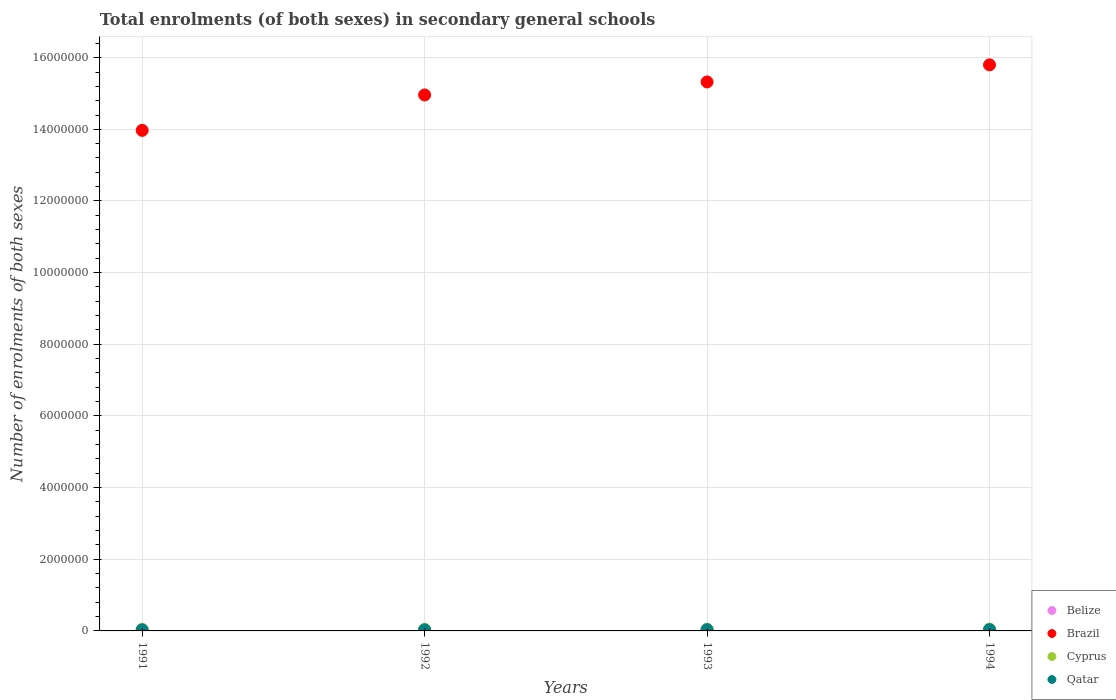How many different coloured dotlines are there?
Your answer should be compact. 4. Is the number of dotlines equal to the number of legend labels?
Your response must be concise. Yes. What is the number of enrolments in secondary schools in Qatar in 1992?
Your answer should be compact. 3.03e+04. Across all years, what is the maximum number of enrolments in secondary schools in Brazil?
Offer a terse response. 1.58e+07. Across all years, what is the minimum number of enrolments in secondary schools in Brazil?
Give a very brief answer. 1.40e+07. In which year was the number of enrolments in secondary schools in Belize maximum?
Ensure brevity in your answer.  1994. What is the total number of enrolments in secondary schools in Qatar in the graph?
Give a very brief answer. 1.29e+05. What is the difference between the number of enrolments in secondary schools in Belize in 1991 and that in 1993?
Offer a terse response. -2189. What is the difference between the number of enrolments in secondary schools in Belize in 1993 and the number of enrolments in secondary schools in Cyprus in 1994?
Give a very brief answer. -3.22e+04. What is the average number of enrolments in secondary schools in Brazil per year?
Your answer should be compact. 1.50e+07. In the year 1994, what is the difference between the number of enrolments in secondary schools in Brazil and number of enrolments in secondary schools in Cyprus?
Your answer should be compact. 1.57e+07. In how many years, is the number of enrolments in secondary schools in Qatar greater than 4400000?
Provide a short and direct response. 0. What is the ratio of the number of enrolments in secondary schools in Qatar in 1993 to that in 1994?
Your answer should be compact. 0.96. What is the difference between the highest and the second highest number of enrolments in secondary schools in Cyprus?
Your answer should be very brief. 2747. What is the difference between the highest and the lowest number of enrolments in secondary schools in Belize?
Keep it short and to the point. 3148. Is the number of enrolments in secondary schools in Brazil strictly greater than the number of enrolments in secondary schools in Qatar over the years?
Provide a short and direct response. Yes. Is the number of enrolments in secondary schools in Qatar strictly less than the number of enrolments in secondary schools in Belize over the years?
Ensure brevity in your answer.  No. What is the difference between two consecutive major ticks on the Y-axis?
Offer a very short reply. 2.00e+06. Are the values on the major ticks of Y-axis written in scientific E-notation?
Give a very brief answer. No. Does the graph contain grids?
Your answer should be very brief. Yes. Where does the legend appear in the graph?
Your response must be concise. Bottom right. How many legend labels are there?
Your response must be concise. 4. What is the title of the graph?
Your answer should be compact. Total enrolments (of both sexes) in secondary general schools. What is the label or title of the X-axis?
Your response must be concise. Years. What is the label or title of the Y-axis?
Give a very brief answer. Number of enrolments of both sexes. What is the Number of enrolments of both sexes in Belize in 1991?
Offer a terse response. 1.64e+04. What is the Number of enrolments of both sexes of Brazil in 1991?
Your answer should be very brief. 1.40e+07. What is the Number of enrolments of both sexes of Cyprus in 1991?
Your answer should be compact. 4.16e+04. What is the Number of enrolments of both sexes of Qatar in 1991?
Offer a very short reply. 2.92e+04. What is the Number of enrolments of both sexes of Belize in 1992?
Offer a terse response. 1.77e+04. What is the Number of enrolments of both sexes of Brazil in 1992?
Offer a very short reply. 1.50e+07. What is the Number of enrolments of both sexes in Cyprus in 1992?
Keep it short and to the point. 4.47e+04. What is the Number of enrolments of both sexes of Qatar in 1992?
Provide a short and direct response. 3.03e+04. What is the Number of enrolments of both sexes of Belize in 1993?
Offer a very short reply. 1.86e+04. What is the Number of enrolments of both sexes in Brazil in 1993?
Give a very brief answer. 1.53e+07. What is the Number of enrolments of both sexes in Cyprus in 1993?
Keep it short and to the point. 4.81e+04. What is the Number of enrolments of both sexes of Qatar in 1993?
Offer a very short reply. 3.42e+04. What is the Number of enrolments of both sexes of Belize in 1994?
Provide a short and direct response. 1.96e+04. What is the Number of enrolments of both sexes in Brazil in 1994?
Keep it short and to the point. 1.58e+07. What is the Number of enrolments of both sexes of Cyprus in 1994?
Provide a short and direct response. 5.09e+04. What is the Number of enrolments of both sexes of Qatar in 1994?
Your answer should be compact. 3.55e+04. Across all years, what is the maximum Number of enrolments of both sexes of Belize?
Provide a short and direct response. 1.96e+04. Across all years, what is the maximum Number of enrolments of both sexes of Brazil?
Make the answer very short. 1.58e+07. Across all years, what is the maximum Number of enrolments of both sexes of Cyprus?
Provide a succinct answer. 5.09e+04. Across all years, what is the maximum Number of enrolments of both sexes in Qatar?
Your answer should be very brief. 3.55e+04. Across all years, what is the minimum Number of enrolments of both sexes in Belize?
Your answer should be very brief. 1.64e+04. Across all years, what is the minimum Number of enrolments of both sexes in Brazil?
Give a very brief answer. 1.40e+07. Across all years, what is the minimum Number of enrolments of both sexes of Cyprus?
Provide a short and direct response. 4.16e+04. Across all years, what is the minimum Number of enrolments of both sexes in Qatar?
Your response must be concise. 2.92e+04. What is the total Number of enrolments of both sexes of Belize in the graph?
Make the answer very short. 7.24e+04. What is the total Number of enrolments of both sexes of Brazil in the graph?
Make the answer very short. 6.01e+07. What is the total Number of enrolments of both sexes in Cyprus in the graph?
Offer a very short reply. 1.85e+05. What is the total Number of enrolments of both sexes in Qatar in the graph?
Keep it short and to the point. 1.29e+05. What is the difference between the Number of enrolments of both sexes of Belize in 1991 and that in 1992?
Your answer should be compact. -1246. What is the difference between the Number of enrolments of both sexes in Brazil in 1991 and that in 1992?
Keep it short and to the point. -9.89e+05. What is the difference between the Number of enrolments of both sexes in Cyprus in 1991 and that in 1992?
Provide a short and direct response. -3152. What is the difference between the Number of enrolments of both sexes of Qatar in 1991 and that in 1992?
Ensure brevity in your answer.  -1123. What is the difference between the Number of enrolments of both sexes of Belize in 1991 and that in 1993?
Provide a short and direct response. -2189. What is the difference between the Number of enrolments of both sexes of Brazil in 1991 and that in 1993?
Make the answer very short. -1.35e+06. What is the difference between the Number of enrolments of both sexes in Cyprus in 1991 and that in 1993?
Offer a terse response. -6539. What is the difference between the Number of enrolments of both sexes of Qatar in 1991 and that in 1993?
Provide a succinct answer. -5077. What is the difference between the Number of enrolments of both sexes in Belize in 1991 and that in 1994?
Keep it short and to the point. -3148. What is the difference between the Number of enrolments of both sexes in Brazil in 1991 and that in 1994?
Your answer should be very brief. -1.83e+06. What is the difference between the Number of enrolments of both sexes of Cyprus in 1991 and that in 1994?
Your response must be concise. -9286. What is the difference between the Number of enrolments of both sexes of Qatar in 1991 and that in 1994?
Ensure brevity in your answer.  -6364. What is the difference between the Number of enrolments of both sexes in Belize in 1992 and that in 1993?
Provide a succinct answer. -943. What is the difference between the Number of enrolments of both sexes in Brazil in 1992 and that in 1993?
Your answer should be very brief. -3.62e+05. What is the difference between the Number of enrolments of both sexes of Cyprus in 1992 and that in 1993?
Your response must be concise. -3387. What is the difference between the Number of enrolments of both sexes of Qatar in 1992 and that in 1993?
Provide a short and direct response. -3954. What is the difference between the Number of enrolments of both sexes of Belize in 1992 and that in 1994?
Provide a succinct answer. -1902. What is the difference between the Number of enrolments of both sexes of Brazil in 1992 and that in 1994?
Make the answer very short. -8.40e+05. What is the difference between the Number of enrolments of both sexes in Cyprus in 1992 and that in 1994?
Your answer should be very brief. -6134. What is the difference between the Number of enrolments of both sexes of Qatar in 1992 and that in 1994?
Keep it short and to the point. -5241. What is the difference between the Number of enrolments of both sexes of Belize in 1993 and that in 1994?
Provide a short and direct response. -959. What is the difference between the Number of enrolments of both sexes in Brazil in 1993 and that in 1994?
Offer a terse response. -4.77e+05. What is the difference between the Number of enrolments of both sexes in Cyprus in 1993 and that in 1994?
Your answer should be compact. -2747. What is the difference between the Number of enrolments of both sexes in Qatar in 1993 and that in 1994?
Give a very brief answer. -1287. What is the difference between the Number of enrolments of both sexes of Belize in 1991 and the Number of enrolments of both sexes of Brazil in 1992?
Your answer should be very brief. -1.49e+07. What is the difference between the Number of enrolments of both sexes in Belize in 1991 and the Number of enrolments of both sexes in Cyprus in 1992?
Give a very brief answer. -2.83e+04. What is the difference between the Number of enrolments of both sexes of Belize in 1991 and the Number of enrolments of both sexes of Qatar in 1992?
Offer a terse response. -1.38e+04. What is the difference between the Number of enrolments of both sexes of Brazil in 1991 and the Number of enrolments of both sexes of Cyprus in 1992?
Provide a short and direct response. 1.39e+07. What is the difference between the Number of enrolments of both sexes of Brazil in 1991 and the Number of enrolments of both sexes of Qatar in 1992?
Offer a terse response. 1.39e+07. What is the difference between the Number of enrolments of both sexes in Cyprus in 1991 and the Number of enrolments of both sexes in Qatar in 1992?
Keep it short and to the point. 1.13e+04. What is the difference between the Number of enrolments of both sexes in Belize in 1991 and the Number of enrolments of both sexes in Brazil in 1993?
Your answer should be compact. -1.53e+07. What is the difference between the Number of enrolments of both sexes in Belize in 1991 and the Number of enrolments of both sexes in Cyprus in 1993?
Keep it short and to the point. -3.17e+04. What is the difference between the Number of enrolments of both sexes in Belize in 1991 and the Number of enrolments of both sexes in Qatar in 1993?
Offer a very short reply. -1.78e+04. What is the difference between the Number of enrolments of both sexes of Brazil in 1991 and the Number of enrolments of both sexes of Cyprus in 1993?
Keep it short and to the point. 1.39e+07. What is the difference between the Number of enrolments of both sexes in Brazil in 1991 and the Number of enrolments of both sexes in Qatar in 1993?
Your answer should be very brief. 1.39e+07. What is the difference between the Number of enrolments of both sexes in Cyprus in 1991 and the Number of enrolments of both sexes in Qatar in 1993?
Give a very brief answer. 7353. What is the difference between the Number of enrolments of both sexes of Belize in 1991 and the Number of enrolments of both sexes of Brazil in 1994?
Make the answer very short. -1.58e+07. What is the difference between the Number of enrolments of both sexes in Belize in 1991 and the Number of enrolments of both sexes in Cyprus in 1994?
Make the answer very short. -3.44e+04. What is the difference between the Number of enrolments of both sexes of Belize in 1991 and the Number of enrolments of both sexes of Qatar in 1994?
Make the answer very short. -1.91e+04. What is the difference between the Number of enrolments of both sexes in Brazil in 1991 and the Number of enrolments of both sexes in Cyprus in 1994?
Your answer should be very brief. 1.39e+07. What is the difference between the Number of enrolments of both sexes of Brazil in 1991 and the Number of enrolments of both sexes of Qatar in 1994?
Offer a terse response. 1.39e+07. What is the difference between the Number of enrolments of both sexes of Cyprus in 1991 and the Number of enrolments of both sexes of Qatar in 1994?
Keep it short and to the point. 6066. What is the difference between the Number of enrolments of both sexes of Belize in 1992 and the Number of enrolments of both sexes of Brazil in 1993?
Offer a terse response. -1.53e+07. What is the difference between the Number of enrolments of both sexes in Belize in 1992 and the Number of enrolments of both sexes in Cyprus in 1993?
Ensure brevity in your answer.  -3.04e+04. What is the difference between the Number of enrolments of both sexes in Belize in 1992 and the Number of enrolments of both sexes in Qatar in 1993?
Your response must be concise. -1.65e+04. What is the difference between the Number of enrolments of both sexes of Brazil in 1992 and the Number of enrolments of both sexes of Cyprus in 1993?
Offer a very short reply. 1.49e+07. What is the difference between the Number of enrolments of both sexes of Brazil in 1992 and the Number of enrolments of both sexes of Qatar in 1993?
Make the answer very short. 1.49e+07. What is the difference between the Number of enrolments of both sexes in Cyprus in 1992 and the Number of enrolments of both sexes in Qatar in 1993?
Provide a short and direct response. 1.05e+04. What is the difference between the Number of enrolments of both sexes of Belize in 1992 and the Number of enrolments of both sexes of Brazil in 1994?
Ensure brevity in your answer.  -1.58e+07. What is the difference between the Number of enrolments of both sexes of Belize in 1992 and the Number of enrolments of both sexes of Cyprus in 1994?
Ensure brevity in your answer.  -3.32e+04. What is the difference between the Number of enrolments of both sexes in Belize in 1992 and the Number of enrolments of both sexes in Qatar in 1994?
Make the answer very short. -1.78e+04. What is the difference between the Number of enrolments of both sexes of Brazil in 1992 and the Number of enrolments of both sexes of Cyprus in 1994?
Offer a very short reply. 1.49e+07. What is the difference between the Number of enrolments of both sexes in Brazil in 1992 and the Number of enrolments of both sexes in Qatar in 1994?
Provide a succinct answer. 1.49e+07. What is the difference between the Number of enrolments of both sexes in Cyprus in 1992 and the Number of enrolments of both sexes in Qatar in 1994?
Offer a terse response. 9218. What is the difference between the Number of enrolments of both sexes in Belize in 1993 and the Number of enrolments of both sexes in Brazil in 1994?
Provide a short and direct response. -1.58e+07. What is the difference between the Number of enrolments of both sexes of Belize in 1993 and the Number of enrolments of both sexes of Cyprus in 1994?
Provide a short and direct response. -3.22e+04. What is the difference between the Number of enrolments of both sexes in Belize in 1993 and the Number of enrolments of both sexes in Qatar in 1994?
Provide a succinct answer. -1.69e+04. What is the difference between the Number of enrolments of both sexes of Brazil in 1993 and the Number of enrolments of both sexes of Cyprus in 1994?
Ensure brevity in your answer.  1.53e+07. What is the difference between the Number of enrolments of both sexes in Brazil in 1993 and the Number of enrolments of both sexes in Qatar in 1994?
Ensure brevity in your answer.  1.53e+07. What is the difference between the Number of enrolments of both sexes of Cyprus in 1993 and the Number of enrolments of both sexes of Qatar in 1994?
Your answer should be very brief. 1.26e+04. What is the average Number of enrolments of both sexes in Belize per year?
Your answer should be compact. 1.81e+04. What is the average Number of enrolments of both sexes in Brazil per year?
Provide a succinct answer. 1.50e+07. What is the average Number of enrolments of both sexes in Cyprus per year?
Offer a terse response. 4.63e+04. What is the average Number of enrolments of both sexes in Qatar per year?
Ensure brevity in your answer.  3.23e+04. In the year 1991, what is the difference between the Number of enrolments of both sexes in Belize and Number of enrolments of both sexes in Brazil?
Offer a very short reply. -1.40e+07. In the year 1991, what is the difference between the Number of enrolments of both sexes of Belize and Number of enrolments of both sexes of Cyprus?
Keep it short and to the point. -2.51e+04. In the year 1991, what is the difference between the Number of enrolments of both sexes of Belize and Number of enrolments of both sexes of Qatar?
Provide a succinct answer. -1.27e+04. In the year 1991, what is the difference between the Number of enrolments of both sexes of Brazil and Number of enrolments of both sexes of Cyprus?
Give a very brief answer. 1.39e+07. In the year 1991, what is the difference between the Number of enrolments of both sexes of Brazil and Number of enrolments of both sexes of Qatar?
Keep it short and to the point. 1.39e+07. In the year 1991, what is the difference between the Number of enrolments of both sexes in Cyprus and Number of enrolments of both sexes in Qatar?
Make the answer very short. 1.24e+04. In the year 1992, what is the difference between the Number of enrolments of both sexes in Belize and Number of enrolments of both sexes in Brazil?
Offer a terse response. -1.49e+07. In the year 1992, what is the difference between the Number of enrolments of both sexes in Belize and Number of enrolments of both sexes in Cyprus?
Offer a very short reply. -2.70e+04. In the year 1992, what is the difference between the Number of enrolments of both sexes of Belize and Number of enrolments of both sexes of Qatar?
Make the answer very short. -1.26e+04. In the year 1992, what is the difference between the Number of enrolments of both sexes of Brazil and Number of enrolments of both sexes of Cyprus?
Provide a short and direct response. 1.49e+07. In the year 1992, what is the difference between the Number of enrolments of both sexes in Brazil and Number of enrolments of both sexes in Qatar?
Give a very brief answer. 1.49e+07. In the year 1992, what is the difference between the Number of enrolments of both sexes of Cyprus and Number of enrolments of both sexes of Qatar?
Provide a short and direct response. 1.45e+04. In the year 1993, what is the difference between the Number of enrolments of both sexes of Belize and Number of enrolments of both sexes of Brazil?
Your answer should be very brief. -1.53e+07. In the year 1993, what is the difference between the Number of enrolments of both sexes of Belize and Number of enrolments of both sexes of Cyprus?
Your answer should be compact. -2.95e+04. In the year 1993, what is the difference between the Number of enrolments of both sexes in Belize and Number of enrolments of both sexes in Qatar?
Make the answer very short. -1.56e+04. In the year 1993, what is the difference between the Number of enrolments of both sexes in Brazil and Number of enrolments of both sexes in Cyprus?
Offer a terse response. 1.53e+07. In the year 1993, what is the difference between the Number of enrolments of both sexes of Brazil and Number of enrolments of both sexes of Qatar?
Your answer should be very brief. 1.53e+07. In the year 1993, what is the difference between the Number of enrolments of both sexes of Cyprus and Number of enrolments of both sexes of Qatar?
Give a very brief answer. 1.39e+04. In the year 1994, what is the difference between the Number of enrolments of both sexes in Belize and Number of enrolments of both sexes in Brazil?
Offer a very short reply. -1.58e+07. In the year 1994, what is the difference between the Number of enrolments of both sexes of Belize and Number of enrolments of both sexes of Cyprus?
Offer a very short reply. -3.13e+04. In the year 1994, what is the difference between the Number of enrolments of both sexes in Belize and Number of enrolments of both sexes in Qatar?
Give a very brief answer. -1.59e+04. In the year 1994, what is the difference between the Number of enrolments of both sexes in Brazil and Number of enrolments of both sexes in Cyprus?
Your response must be concise. 1.57e+07. In the year 1994, what is the difference between the Number of enrolments of both sexes in Brazil and Number of enrolments of both sexes in Qatar?
Your answer should be compact. 1.58e+07. In the year 1994, what is the difference between the Number of enrolments of both sexes of Cyprus and Number of enrolments of both sexes of Qatar?
Provide a succinct answer. 1.54e+04. What is the ratio of the Number of enrolments of both sexes of Belize in 1991 to that in 1992?
Your response must be concise. 0.93. What is the ratio of the Number of enrolments of both sexes in Brazil in 1991 to that in 1992?
Make the answer very short. 0.93. What is the ratio of the Number of enrolments of both sexes of Cyprus in 1991 to that in 1992?
Make the answer very short. 0.93. What is the ratio of the Number of enrolments of both sexes of Qatar in 1991 to that in 1992?
Offer a very short reply. 0.96. What is the ratio of the Number of enrolments of both sexes of Belize in 1991 to that in 1993?
Give a very brief answer. 0.88. What is the ratio of the Number of enrolments of both sexes in Brazil in 1991 to that in 1993?
Your response must be concise. 0.91. What is the ratio of the Number of enrolments of both sexes of Cyprus in 1991 to that in 1993?
Your answer should be very brief. 0.86. What is the ratio of the Number of enrolments of both sexes in Qatar in 1991 to that in 1993?
Provide a succinct answer. 0.85. What is the ratio of the Number of enrolments of both sexes of Belize in 1991 to that in 1994?
Offer a terse response. 0.84. What is the ratio of the Number of enrolments of both sexes of Brazil in 1991 to that in 1994?
Your answer should be very brief. 0.88. What is the ratio of the Number of enrolments of both sexes of Cyprus in 1991 to that in 1994?
Offer a terse response. 0.82. What is the ratio of the Number of enrolments of both sexes in Qatar in 1991 to that in 1994?
Offer a very short reply. 0.82. What is the ratio of the Number of enrolments of both sexes in Belize in 1992 to that in 1993?
Keep it short and to the point. 0.95. What is the ratio of the Number of enrolments of both sexes of Brazil in 1992 to that in 1993?
Ensure brevity in your answer.  0.98. What is the ratio of the Number of enrolments of both sexes of Cyprus in 1992 to that in 1993?
Keep it short and to the point. 0.93. What is the ratio of the Number of enrolments of both sexes of Qatar in 1992 to that in 1993?
Provide a short and direct response. 0.88. What is the ratio of the Number of enrolments of both sexes of Belize in 1992 to that in 1994?
Offer a very short reply. 0.9. What is the ratio of the Number of enrolments of both sexes in Brazil in 1992 to that in 1994?
Give a very brief answer. 0.95. What is the ratio of the Number of enrolments of both sexes of Cyprus in 1992 to that in 1994?
Offer a terse response. 0.88. What is the ratio of the Number of enrolments of both sexes of Qatar in 1992 to that in 1994?
Make the answer very short. 0.85. What is the ratio of the Number of enrolments of both sexes in Belize in 1993 to that in 1994?
Your answer should be compact. 0.95. What is the ratio of the Number of enrolments of both sexes of Brazil in 1993 to that in 1994?
Your answer should be compact. 0.97. What is the ratio of the Number of enrolments of both sexes in Cyprus in 1993 to that in 1994?
Offer a very short reply. 0.95. What is the ratio of the Number of enrolments of both sexes of Qatar in 1993 to that in 1994?
Your answer should be compact. 0.96. What is the difference between the highest and the second highest Number of enrolments of both sexes in Belize?
Make the answer very short. 959. What is the difference between the highest and the second highest Number of enrolments of both sexes in Brazil?
Keep it short and to the point. 4.77e+05. What is the difference between the highest and the second highest Number of enrolments of both sexes in Cyprus?
Give a very brief answer. 2747. What is the difference between the highest and the second highest Number of enrolments of both sexes of Qatar?
Provide a succinct answer. 1287. What is the difference between the highest and the lowest Number of enrolments of both sexes of Belize?
Your answer should be compact. 3148. What is the difference between the highest and the lowest Number of enrolments of both sexes in Brazil?
Offer a terse response. 1.83e+06. What is the difference between the highest and the lowest Number of enrolments of both sexes in Cyprus?
Keep it short and to the point. 9286. What is the difference between the highest and the lowest Number of enrolments of both sexes of Qatar?
Provide a succinct answer. 6364. 